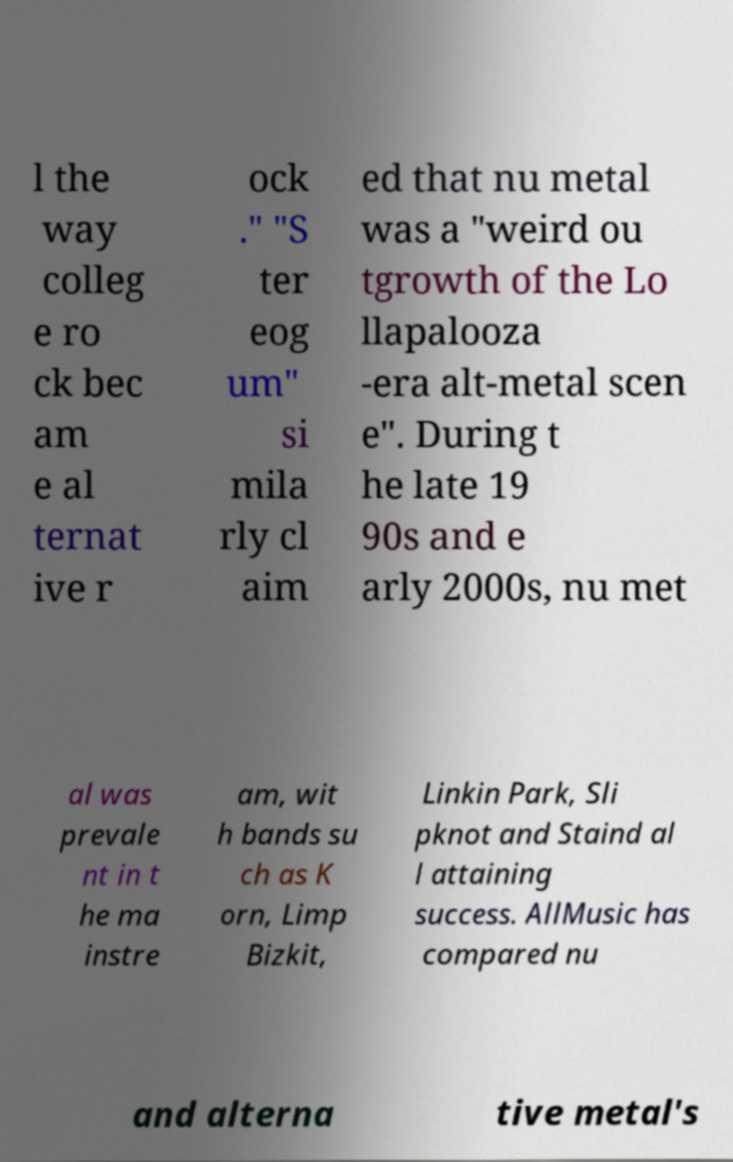Can you read and provide the text displayed in the image?This photo seems to have some interesting text. Can you extract and type it out for me? l the way colleg e ro ck bec am e al ternat ive r ock ." "S ter eog um" si mila rly cl aim ed that nu metal was a "weird ou tgrowth of the Lo llapalooza -era alt-metal scen e". During t he late 19 90s and e arly 2000s, nu met al was prevale nt in t he ma instre am, wit h bands su ch as K orn, Limp Bizkit, Linkin Park, Sli pknot and Staind al l attaining success. AllMusic has compared nu and alterna tive metal's 